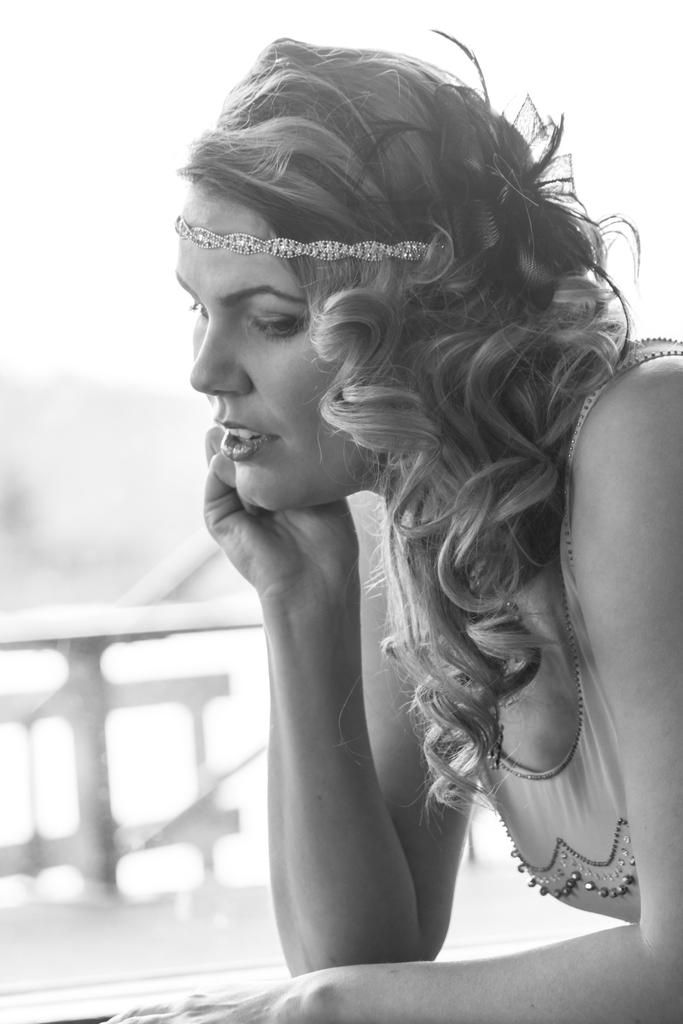Who is the main subject in the foreground of the image? There is a woman in the foreground of the image. On which side of the image is the woman located? The woman is on the right side of the image. What can be observed about the background of the image? The background of the image is blurred. What color scheme is used in the image? The image is in black and white. What type of quiver can be seen on the woman's back in the image? There is no quiver present on the woman's back in the image. What color is the sky in the image? The image is in black and white, so it is not possible to determine the color of the sky. 